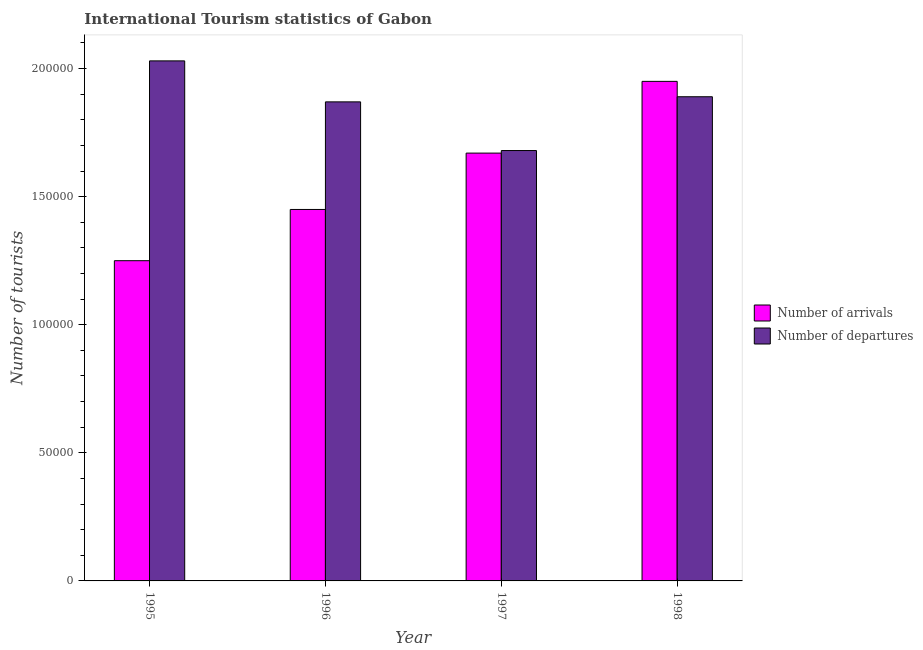How many different coloured bars are there?
Offer a terse response. 2. What is the label of the 1st group of bars from the left?
Provide a short and direct response. 1995. What is the number of tourist arrivals in 1997?
Your answer should be compact. 1.67e+05. Across all years, what is the maximum number of tourist departures?
Provide a short and direct response. 2.03e+05. Across all years, what is the minimum number of tourist arrivals?
Your answer should be compact. 1.25e+05. In which year was the number of tourist departures maximum?
Make the answer very short. 1995. What is the total number of tourist arrivals in the graph?
Make the answer very short. 6.32e+05. What is the difference between the number of tourist departures in 1995 and that in 1998?
Make the answer very short. 1.40e+04. What is the difference between the number of tourist arrivals in 1995 and the number of tourist departures in 1998?
Your response must be concise. -7.00e+04. What is the average number of tourist arrivals per year?
Give a very brief answer. 1.58e+05. In the year 1996, what is the difference between the number of tourist arrivals and number of tourist departures?
Provide a succinct answer. 0. In how many years, is the number of tourist departures greater than 120000?
Make the answer very short. 4. What is the ratio of the number of tourist departures in 1995 to that in 1997?
Make the answer very short. 1.21. Is the number of tourist departures in 1995 less than that in 1996?
Your answer should be compact. No. What is the difference between the highest and the second highest number of tourist departures?
Provide a short and direct response. 1.40e+04. What is the difference between the highest and the lowest number of tourist departures?
Your answer should be compact. 3.50e+04. In how many years, is the number of tourist arrivals greater than the average number of tourist arrivals taken over all years?
Give a very brief answer. 2. Is the sum of the number of tourist departures in 1995 and 1997 greater than the maximum number of tourist arrivals across all years?
Your response must be concise. Yes. What does the 2nd bar from the left in 1996 represents?
Your answer should be very brief. Number of departures. What does the 2nd bar from the right in 1997 represents?
Provide a short and direct response. Number of arrivals. How many years are there in the graph?
Give a very brief answer. 4. What is the difference between two consecutive major ticks on the Y-axis?
Your response must be concise. 5.00e+04. Where does the legend appear in the graph?
Your answer should be very brief. Center right. How are the legend labels stacked?
Offer a very short reply. Vertical. What is the title of the graph?
Your answer should be very brief. International Tourism statistics of Gabon. What is the label or title of the X-axis?
Your response must be concise. Year. What is the label or title of the Y-axis?
Provide a short and direct response. Number of tourists. What is the Number of tourists of Number of arrivals in 1995?
Keep it short and to the point. 1.25e+05. What is the Number of tourists in Number of departures in 1995?
Ensure brevity in your answer.  2.03e+05. What is the Number of tourists of Number of arrivals in 1996?
Ensure brevity in your answer.  1.45e+05. What is the Number of tourists of Number of departures in 1996?
Keep it short and to the point. 1.87e+05. What is the Number of tourists of Number of arrivals in 1997?
Offer a terse response. 1.67e+05. What is the Number of tourists of Number of departures in 1997?
Ensure brevity in your answer.  1.68e+05. What is the Number of tourists of Number of arrivals in 1998?
Give a very brief answer. 1.95e+05. What is the Number of tourists of Number of departures in 1998?
Keep it short and to the point. 1.89e+05. Across all years, what is the maximum Number of tourists of Number of arrivals?
Provide a short and direct response. 1.95e+05. Across all years, what is the maximum Number of tourists of Number of departures?
Your answer should be very brief. 2.03e+05. Across all years, what is the minimum Number of tourists in Number of arrivals?
Offer a terse response. 1.25e+05. Across all years, what is the minimum Number of tourists in Number of departures?
Your answer should be compact. 1.68e+05. What is the total Number of tourists in Number of arrivals in the graph?
Make the answer very short. 6.32e+05. What is the total Number of tourists in Number of departures in the graph?
Give a very brief answer. 7.47e+05. What is the difference between the Number of tourists in Number of departures in 1995 and that in 1996?
Provide a succinct answer. 1.60e+04. What is the difference between the Number of tourists of Number of arrivals in 1995 and that in 1997?
Give a very brief answer. -4.20e+04. What is the difference between the Number of tourists in Number of departures in 1995 and that in 1997?
Make the answer very short. 3.50e+04. What is the difference between the Number of tourists in Number of arrivals in 1995 and that in 1998?
Make the answer very short. -7.00e+04. What is the difference between the Number of tourists in Number of departures in 1995 and that in 1998?
Ensure brevity in your answer.  1.40e+04. What is the difference between the Number of tourists in Number of arrivals in 1996 and that in 1997?
Give a very brief answer. -2.20e+04. What is the difference between the Number of tourists in Number of departures in 1996 and that in 1997?
Give a very brief answer. 1.90e+04. What is the difference between the Number of tourists of Number of arrivals in 1996 and that in 1998?
Offer a very short reply. -5.00e+04. What is the difference between the Number of tourists in Number of departures in 1996 and that in 1998?
Your response must be concise. -2000. What is the difference between the Number of tourists of Number of arrivals in 1997 and that in 1998?
Make the answer very short. -2.80e+04. What is the difference between the Number of tourists in Number of departures in 1997 and that in 1998?
Your answer should be very brief. -2.10e+04. What is the difference between the Number of tourists in Number of arrivals in 1995 and the Number of tourists in Number of departures in 1996?
Your answer should be compact. -6.20e+04. What is the difference between the Number of tourists of Number of arrivals in 1995 and the Number of tourists of Number of departures in 1997?
Offer a very short reply. -4.30e+04. What is the difference between the Number of tourists of Number of arrivals in 1995 and the Number of tourists of Number of departures in 1998?
Provide a short and direct response. -6.40e+04. What is the difference between the Number of tourists in Number of arrivals in 1996 and the Number of tourists in Number of departures in 1997?
Offer a very short reply. -2.30e+04. What is the difference between the Number of tourists of Number of arrivals in 1996 and the Number of tourists of Number of departures in 1998?
Offer a terse response. -4.40e+04. What is the difference between the Number of tourists in Number of arrivals in 1997 and the Number of tourists in Number of departures in 1998?
Ensure brevity in your answer.  -2.20e+04. What is the average Number of tourists in Number of arrivals per year?
Keep it short and to the point. 1.58e+05. What is the average Number of tourists in Number of departures per year?
Your answer should be very brief. 1.87e+05. In the year 1995, what is the difference between the Number of tourists in Number of arrivals and Number of tourists in Number of departures?
Your answer should be compact. -7.80e+04. In the year 1996, what is the difference between the Number of tourists of Number of arrivals and Number of tourists of Number of departures?
Your answer should be compact. -4.20e+04. In the year 1997, what is the difference between the Number of tourists of Number of arrivals and Number of tourists of Number of departures?
Ensure brevity in your answer.  -1000. In the year 1998, what is the difference between the Number of tourists of Number of arrivals and Number of tourists of Number of departures?
Your response must be concise. 6000. What is the ratio of the Number of tourists in Number of arrivals in 1995 to that in 1996?
Give a very brief answer. 0.86. What is the ratio of the Number of tourists in Number of departures in 1995 to that in 1996?
Keep it short and to the point. 1.09. What is the ratio of the Number of tourists in Number of arrivals in 1995 to that in 1997?
Ensure brevity in your answer.  0.75. What is the ratio of the Number of tourists in Number of departures in 1995 to that in 1997?
Keep it short and to the point. 1.21. What is the ratio of the Number of tourists of Number of arrivals in 1995 to that in 1998?
Your answer should be compact. 0.64. What is the ratio of the Number of tourists in Number of departures in 1995 to that in 1998?
Keep it short and to the point. 1.07. What is the ratio of the Number of tourists in Number of arrivals in 1996 to that in 1997?
Give a very brief answer. 0.87. What is the ratio of the Number of tourists in Number of departures in 1996 to that in 1997?
Ensure brevity in your answer.  1.11. What is the ratio of the Number of tourists in Number of arrivals in 1996 to that in 1998?
Your answer should be compact. 0.74. What is the ratio of the Number of tourists in Number of arrivals in 1997 to that in 1998?
Keep it short and to the point. 0.86. What is the ratio of the Number of tourists of Number of departures in 1997 to that in 1998?
Offer a very short reply. 0.89. What is the difference between the highest and the second highest Number of tourists of Number of arrivals?
Your answer should be compact. 2.80e+04. What is the difference between the highest and the second highest Number of tourists in Number of departures?
Your response must be concise. 1.40e+04. What is the difference between the highest and the lowest Number of tourists in Number of departures?
Keep it short and to the point. 3.50e+04. 